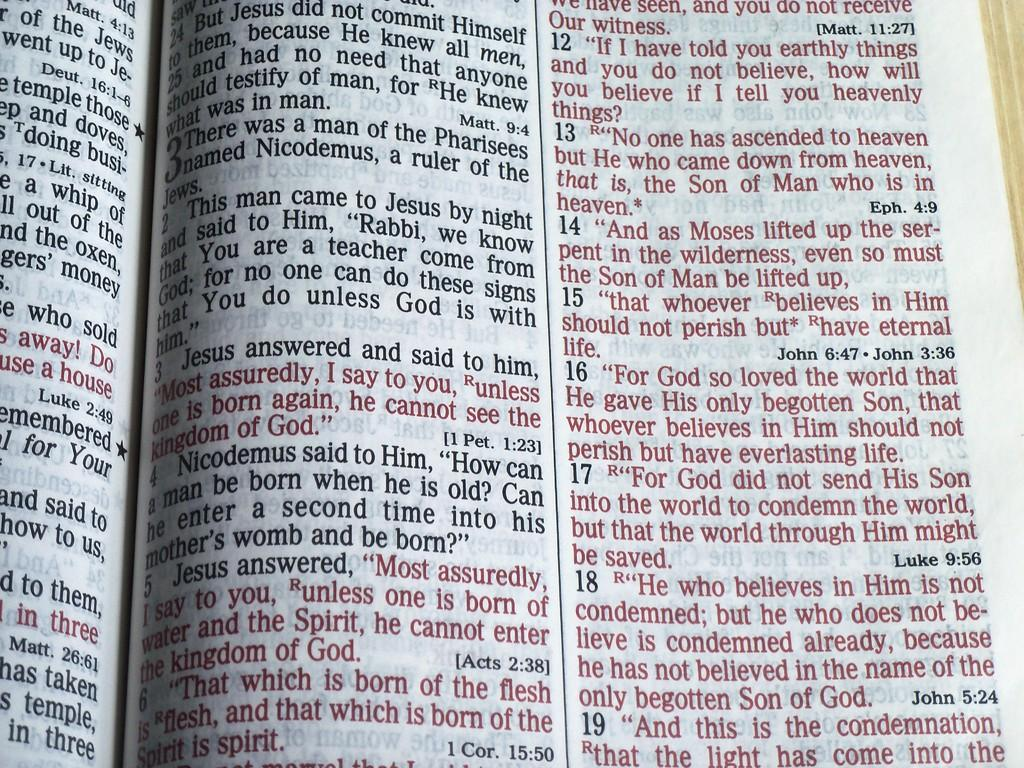<image>
Present a compact description of the photo's key features. A bible lies open displaying verses of text. 